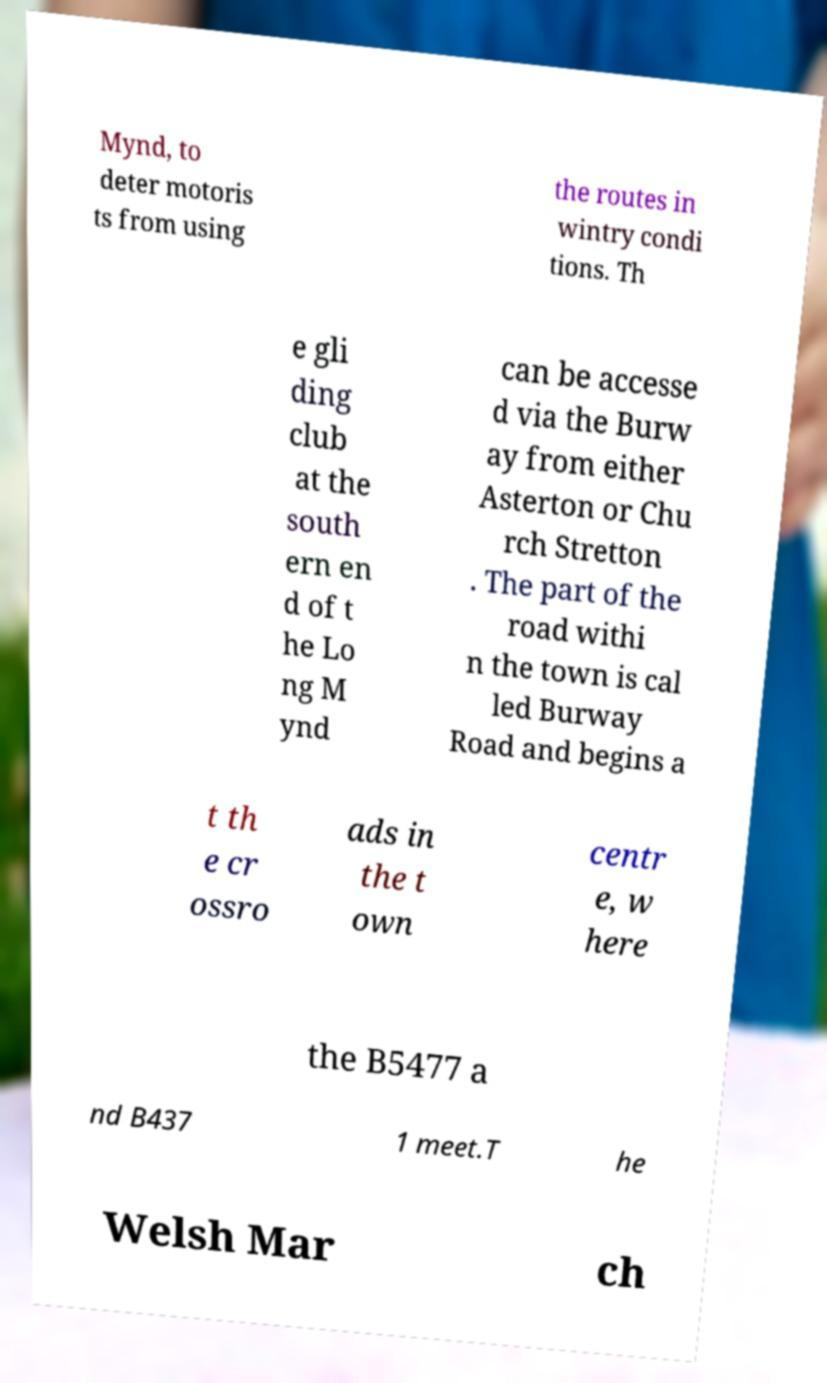I need the written content from this picture converted into text. Can you do that? Mynd, to deter motoris ts from using the routes in wintry condi tions. Th e gli ding club at the south ern en d of t he Lo ng M ynd can be accesse d via the Burw ay from either Asterton or Chu rch Stretton . The part of the road withi n the town is cal led Burway Road and begins a t th e cr ossro ads in the t own centr e, w here the B5477 a nd B437 1 meet.T he Welsh Mar ch 